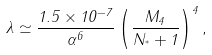<formula> <loc_0><loc_0><loc_500><loc_500>\lambda \simeq \frac { 1 . 5 \times 1 0 ^ { - 7 } } { \alpha ^ { 6 } } \left ( \frac { M _ { 4 } } { N _ { ^ { * } } + 1 } \right ) ^ { 4 } ,</formula> 